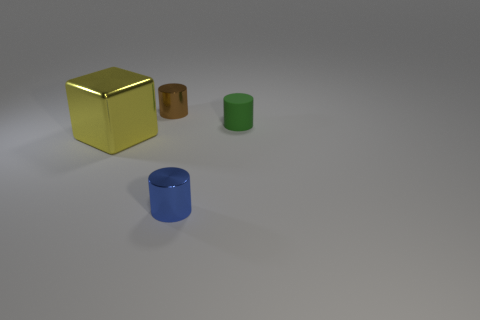Add 1 large blocks. How many objects exist? 5 Subtract all cylinders. How many objects are left? 1 Subtract 0 red cubes. How many objects are left? 4 Subtract all yellow balls. Subtract all small blue cylinders. How many objects are left? 3 Add 4 big metal objects. How many big metal objects are left? 5 Add 1 green matte things. How many green matte things exist? 2 